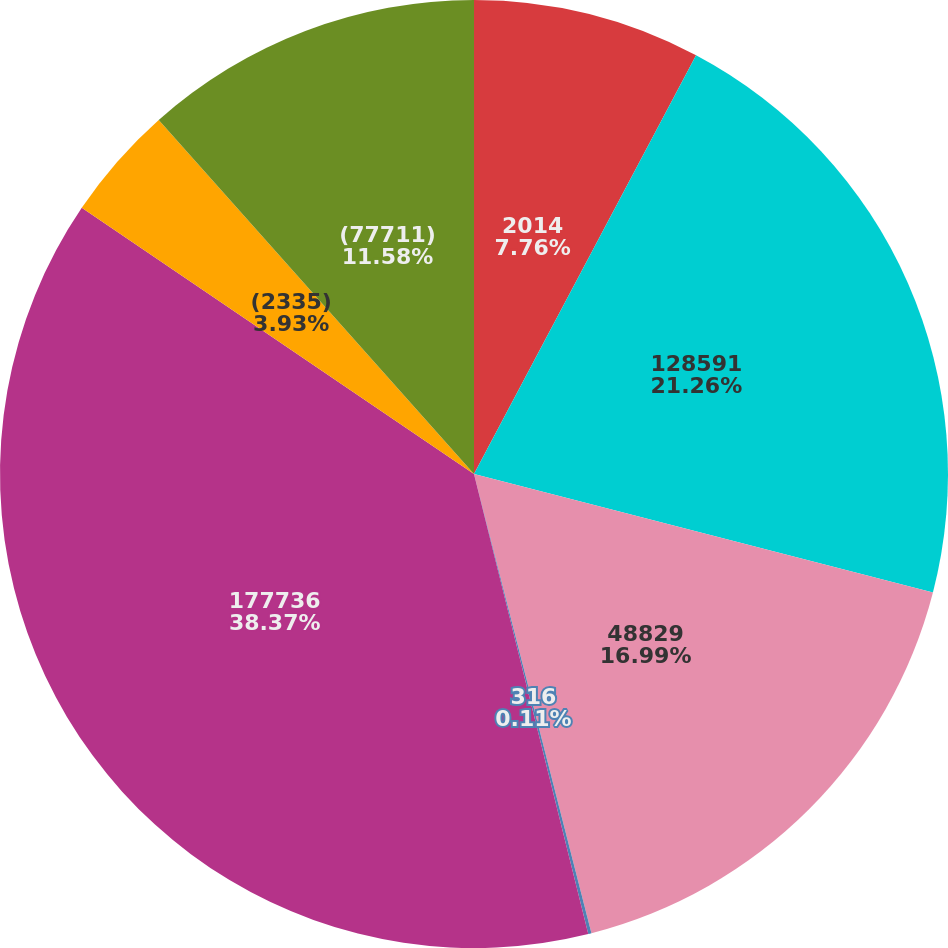Convert chart to OTSL. <chart><loc_0><loc_0><loc_500><loc_500><pie_chart><fcel>2014<fcel>128591<fcel>48829<fcel>316<fcel>177736<fcel>(2335)<fcel>(77711)<nl><fcel>7.76%<fcel>21.26%<fcel>16.99%<fcel>0.11%<fcel>38.36%<fcel>3.93%<fcel>11.58%<nl></chart> 